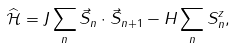<formula> <loc_0><loc_0><loc_500><loc_500>\widehat { \mathcal { H } } = J \sum _ { n } \vec { S } _ { n } \cdot \vec { S } _ { n + 1 } - H \sum _ { n } S ^ { z } _ { n } ,</formula> 